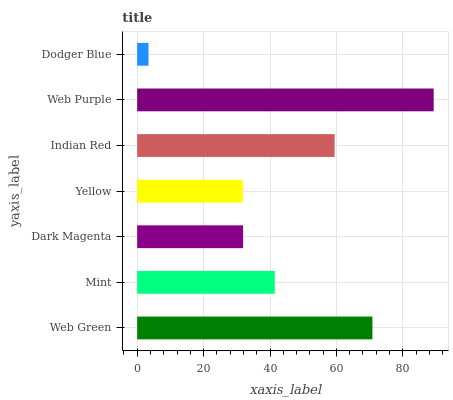Is Dodger Blue the minimum?
Answer yes or no. Yes. Is Web Purple the maximum?
Answer yes or no. Yes. Is Mint the minimum?
Answer yes or no. No. Is Mint the maximum?
Answer yes or no. No. Is Web Green greater than Mint?
Answer yes or no. Yes. Is Mint less than Web Green?
Answer yes or no. Yes. Is Mint greater than Web Green?
Answer yes or no. No. Is Web Green less than Mint?
Answer yes or no. No. Is Mint the high median?
Answer yes or no. Yes. Is Mint the low median?
Answer yes or no. Yes. Is Dodger Blue the high median?
Answer yes or no. No. Is Web Purple the low median?
Answer yes or no. No. 